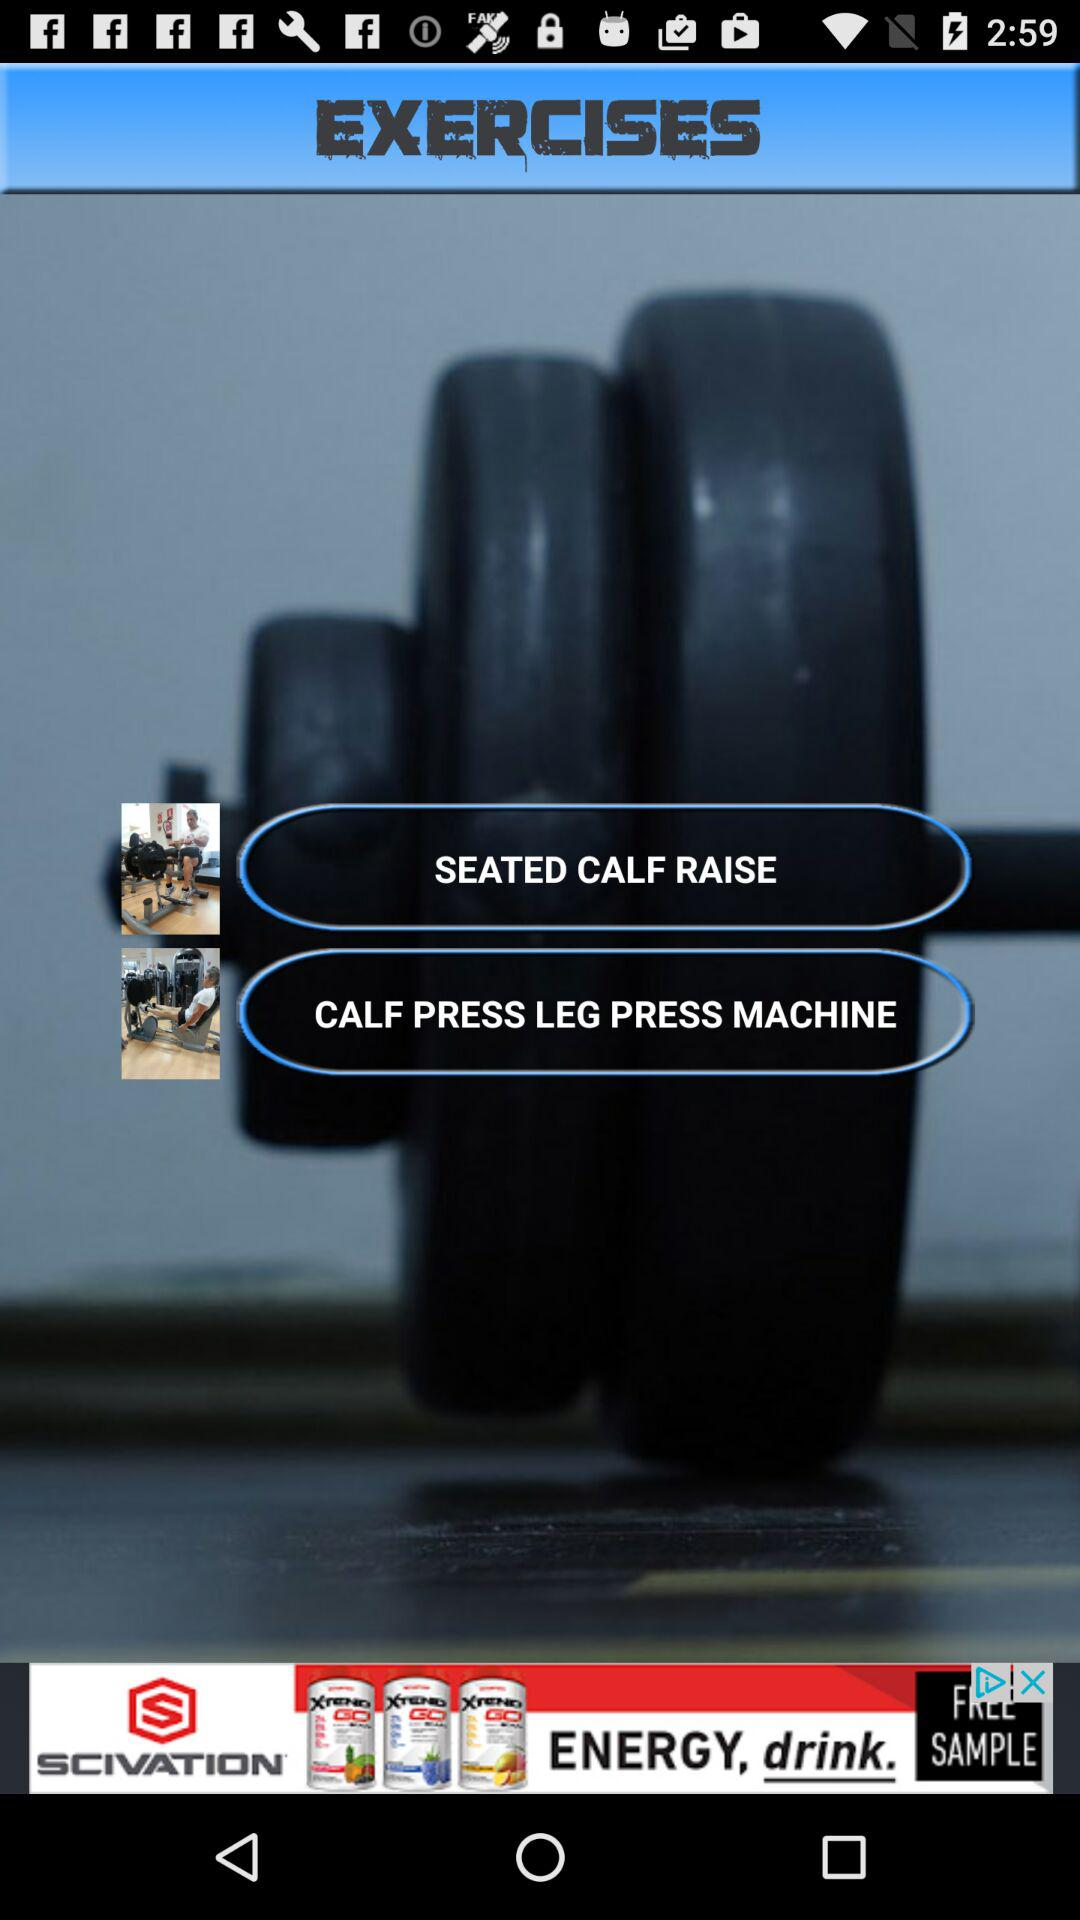How many exercises are there?
Answer the question using a single word or phrase. 2 